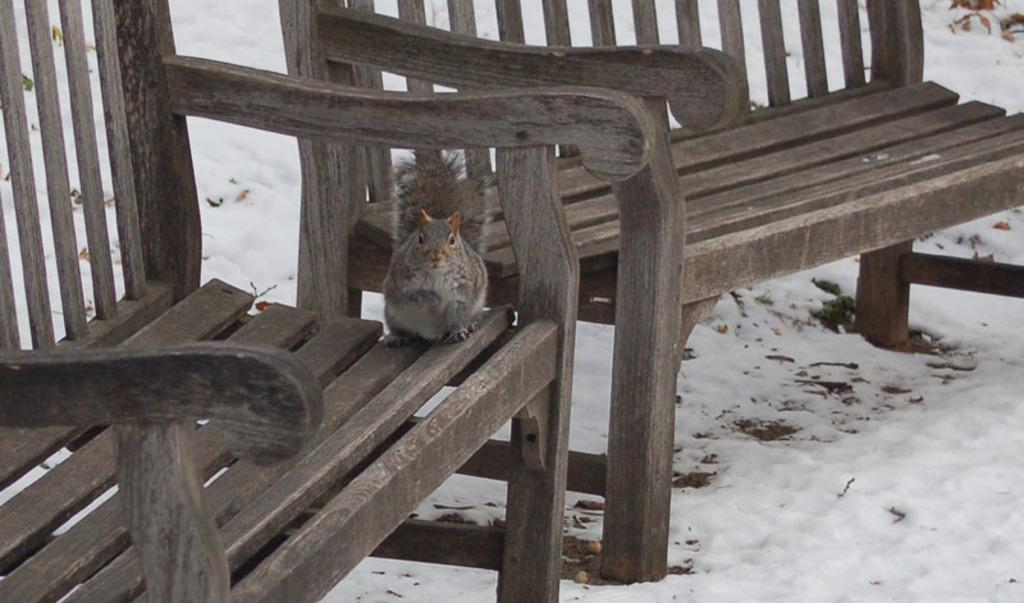How many benches are in the image? There are two benches in the image. What is on the front bench? There is a squirrel on the front bench. What can be seen in the background of the image? There is snow visible in the background of the image. What type of yam is the squirrel holding in the image? There is no yam present in the image; the squirrel is not holding anything. Can you tell me how many guns are visible in the image? There are no guns present in the image. 